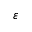Convert formula to latex. <formula><loc_0><loc_0><loc_500><loc_500>\boldsymbol \varepsilon</formula> 